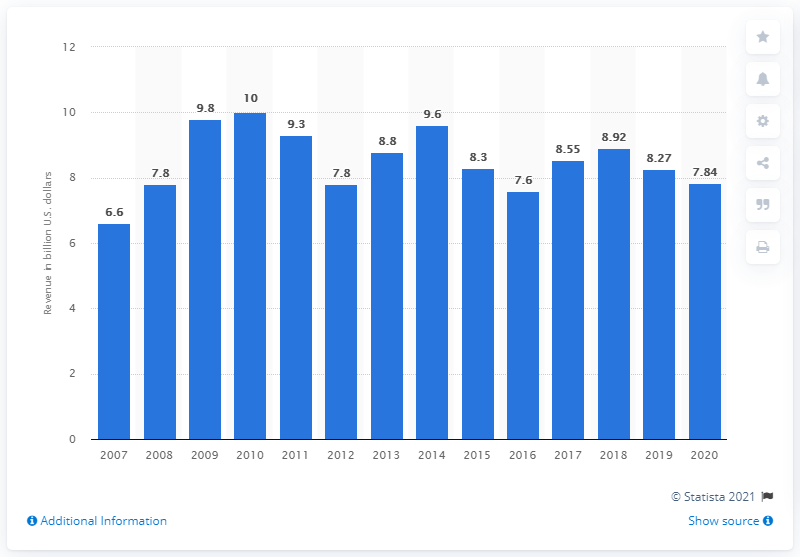Draw attention to some important aspects in this diagram. In 2020, the transportation revenue for Bombardier was 7.84 million. 